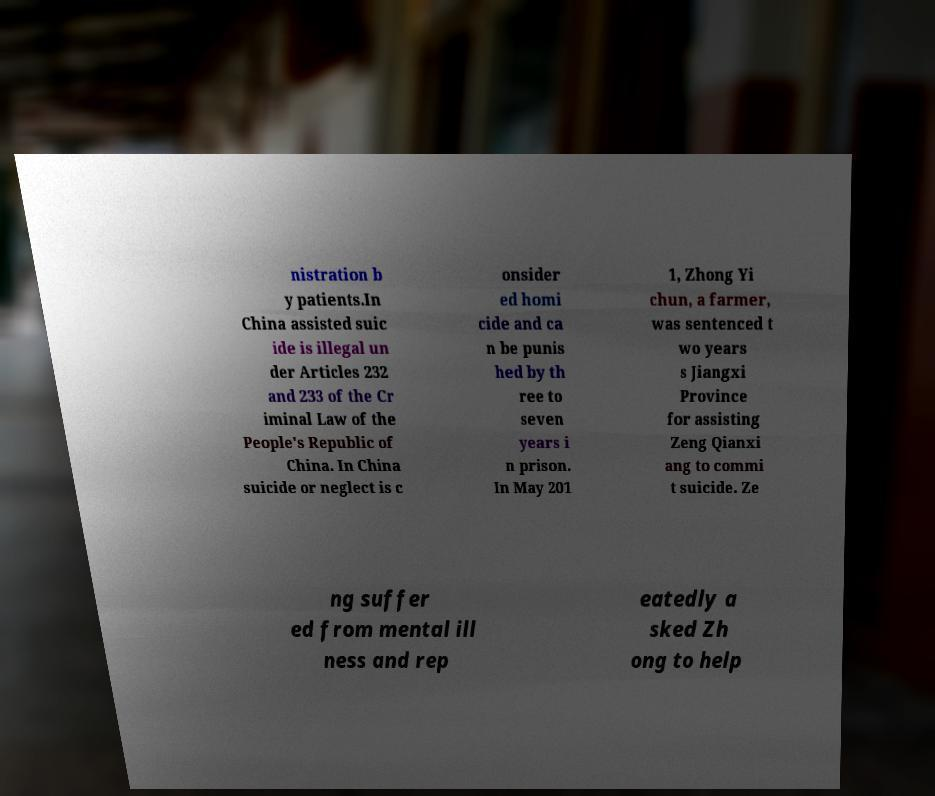For documentation purposes, I need the text within this image transcribed. Could you provide that? nistration b y patients.In China assisted suic ide is illegal un der Articles 232 and 233 of the Cr iminal Law of the People's Republic of China. In China suicide or neglect is c onsider ed homi cide and ca n be punis hed by th ree to seven years i n prison. In May 201 1, Zhong Yi chun, a farmer, was sentenced t wo years s Jiangxi Province for assisting Zeng Qianxi ang to commi t suicide. Ze ng suffer ed from mental ill ness and rep eatedly a sked Zh ong to help 